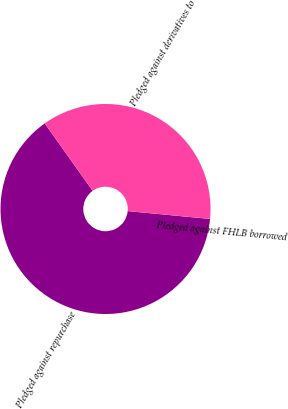<chart> <loc_0><loc_0><loc_500><loc_500><pie_chart><fcel>Pledged against repurchase<fcel>Pledged against FHLB borrowed<fcel>Pledged against derivatives to<nl><fcel>63.65%<fcel>0.01%<fcel>36.33%<nl></chart> 